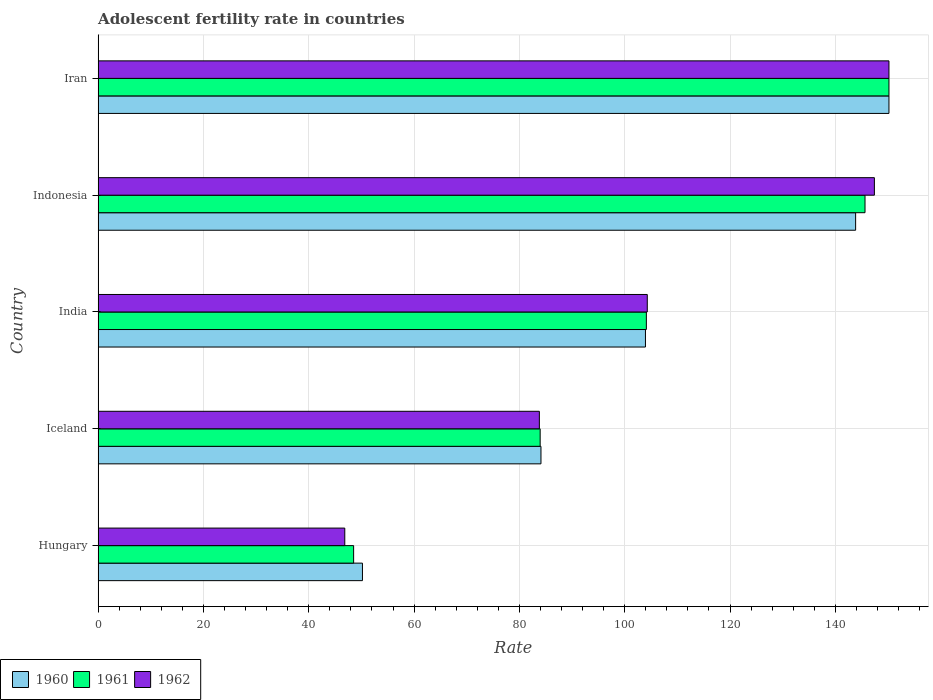How many bars are there on the 4th tick from the top?
Provide a succinct answer. 3. In how many cases, is the number of bars for a given country not equal to the number of legend labels?
Your answer should be very brief. 0. What is the adolescent fertility rate in 1960 in India?
Your answer should be compact. 103.94. Across all countries, what is the maximum adolescent fertility rate in 1962?
Ensure brevity in your answer.  150.18. Across all countries, what is the minimum adolescent fertility rate in 1962?
Your answer should be compact. 46.84. In which country was the adolescent fertility rate in 1962 maximum?
Your response must be concise. Iran. In which country was the adolescent fertility rate in 1962 minimum?
Offer a very short reply. Hungary. What is the total adolescent fertility rate in 1961 in the graph?
Provide a short and direct response. 532.39. What is the difference between the adolescent fertility rate in 1962 in Iceland and that in India?
Your response must be concise. -20.5. What is the difference between the adolescent fertility rate in 1960 in Iceland and the adolescent fertility rate in 1962 in Indonesia?
Ensure brevity in your answer.  -63.32. What is the average adolescent fertility rate in 1961 per country?
Provide a short and direct response. 106.48. What is the difference between the adolescent fertility rate in 1960 and adolescent fertility rate in 1961 in India?
Give a very brief answer. -0.17. In how many countries, is the adolescent fertility rate in 1961 greater than 16 ?
Your answer should be very brief. 5. What is the ratio of the adolescent fertility rate in 1960 in India to that in Iran?
Your answer should be very brief. 0.69. Is the adolescent fertility rate in 1961 in India less than that in Iran?
Provide a succinct answer. Yes. What is the difference between the highest and the second highest adolescent fertility rate in 1960?
Offer a terse response. 6.33. What is the difference between the highest and the lowest adolescent fertility rate in 1962?
Offer a very short reply. 103.34. Is the sum of the adolescent fertility rate in 1960 in India and Iran greater than the maximum adolescent fertility rate in 1962 across all countries?
Provide a succinct answer. Yes. What does the 3rd bar from the top in Indonesia represents?
Keep it short and to the point. 1960. What does the 2nd bar from the bottom in India represents?
Keep it short and to the point. 1961. Are all the bars in the graph horizontal?
Offer a terse response. Yes. How many countries are there in the graph?
Make the answer very short. 5. Does the graph contain any zero values?
Your response must be concise. No. Does the graph contain grids?
Your answer should be compact. Yes. Where does the legend appear in the graph?
Provide a succinct answer. Bottom left. How many legend labels are there?
Provide a succinct answer. 3. How are the legend labels stacked?
Give a very brief answer. Horizontal. What is the title of the graph?
Your answer should be very brief. Adolescent fertility rate in countries. Does "2011" appear as one of the legend labels in the graph?
Keep it short and to the point. No. What is the label or title of the X-axis?
Ensure brevity in your answer.  Rate. What is the label or title of the Y-axis?
Offer a very short reply. Country. What is the Rate in 1960 in Hungary?
Ensure brevity in your answer.  50.2. What is the Rate of 1961 in Hungary?
Your response must be concise. 48.52. What is the Rate of 1962 in Hungary?
Provide a short and direct response. 46.84. What is the Rate in 1960 in Iceland?
Make the answer very short. 84.1. What is the Rate of 1961 in Iceland?
Provide a succinct answer. 83.94. What is the Rate in 1962 in Iceland?
Keep it short and to the point. 83.79. What is the Rate of 1960 in India?
Offer a terse response. 103.94. What is the Rate of 1961 in India?
Make the answer very short. 104.11. What is the Rate in 1962 in India?
Provide a succinct answer. 104.29. What is the Rate in 1960 in Indonesia?
Ensure brevity in your answer.  143.85. What is the Rate in 1961 in Indonesia?
Your response must be concise. 145.63. What is the Rate of 1962 in Indonesia?
Your response must be concise. 147.41. What is the Rate in 1960 in Iran?
Your answer should be very brief. 150.18. What is the Rate in 1961 in Iran?
Your response must be concise. 150.18. What is the Rate of 1962 in Iran?
Provide a short and direct response. 150.18. Across all countries, what is the maximum Rate of 1960?
Provide a succinct answer. 150.18. Across all countries, what is the maximum Rate of 1961?
Your response must be concise. 150.18. Across all countries, what is the maximum Rate of 1962?
Give a very brief answer. 150.18. Across all countries, what is the minimum Rate of 1960?
Your response must be concise. 50.2. Across all countries, what is the minimum Rate in 1961?
Provide a short and direct response. 48.52. Across all countries, what is the minimum Rate of 1962?
Provide a succinct answer. 46.84. What is the total Rate in 1960 in the graph?
Your answer should be compact. 532.26. What is the total Rate of 1961 in the graph?
Your answer should be compact. 532.39. What is the total Rate in 1962 in the graph?
Your answer should be very brief. 532.51. What is the difference between the Rate of 1960 in Hungary and that in Iceland?
Provide a short and direct response. -33.9. What is the difference between the Rate in 1961 in Hungary and that in Iceland?
Offer a very short reply. -35.42. What is the difference between the Rate of 1962 in Hungary and that in Iceland?
Your answer should be very brief. -36.95. What is the difference between the Rate in 1960 in Hungary and that in India?
Keep it short and to the point. -53.74. What is the difference between the Rate in 1961 in Hungary and that in India?
Ensure brevity in your answer.  -55.59. What is the difference between the Rate of 1962 in Hungary and that in India?
Provide a short and direct response. -57.45. What is the difference between the Rate of 1960 in Hungary and that in Indonesia?
Keep it short and to the point. -93.65. What is the difference between the Rate in 1961 in Hungary and that in Indonesia?
Make the answer very short. -97.11. What is the difference between the Rate of 1962 in Hungary and that in Indonesia?
Keep it short and to the point. -100.57. What is the difference between the Rate of 1960 in Hungary and that in Iran?
Offer a very short reply. -99.98. What is the difference between the Rate of 1961 in Hungary and that in Iran?
Offer a very short reply. -101.66. What is the difference between the Rate in 1962 in Hungary and that in Iran?
Make the answer very short. -103.34. What is the difference between the Rate of 1960 in Iceland and that in India?
Keep it short and to the point. -19.84. What is the difference between the Rate in 1961 in Iceland and that in India?
Keep it short and to the point. -20.17. What is the difference between the Rate of 1962 in Iceland and that in India?
Ensure brevity in your answer.  -20.5. What is the difference between the Rate in 1960 in Iceland and that in Indonesia?
Give a very brief answer. -59.75. What is the difference between the Rate in 1961 in Iceland and that in Indonesia?
Give a very brief answer. -61.69. What is the difference between the Rate of 1962 in Iceland and that in Indonesia?
Provide a short and direct response. -63.62. What is the difference between the Rate of 1960 in Iceland and that in Iran?
Ensure brevity in your answer.  -66.08. What is the difference between the Rate in 1961 in Iceland and that in Iran?
Your answer should be very brief. -66.23. What is the difference between the Rate in 1962 in Iceland and that in Iran?
Provide a succinct answer. -66.39. What is the difference between the Rate in 1960 in India and that in Indonesia?
Your answer should be compact. -39.91. What is the difference between the Rate in 1961 in India and that in Indonesia?
Your response must be concise. -41.52. What is the difference between the Rate in 1962 in India and that in Indonesia?
Give a very brief answer. -43.13. What is the difference between the Rate in 1960 in India and that in Iran?
Ensure brevity in your answer.  -46.24. What is the difference between the Rate of 1961 in India and that in Iran?
Provide a short and direct response. -46.07. What is the difference between the Rate in 1962 in India and that in Iran?
Offer a terse response. -45.89. What is the difference between the Rate in 1960 in Indonesia and that in Iran?
Provide a short and direct response. -6.33. What is the difference between the Rate of 1961 in Indonesia and that in Iran?
Keep it short and to the point. -4.55. What is the difference between the Rate of 1962 in Indonesia and that in Iran?
Your answer should be compact. -2.77. What is the difference between the Rate in 1960 in Hungary and the Rate in 1961 in Iceland?
Ensure brevity in your answer.  -33.75. What is the difference between the Rate in 1960 in Hungary and the Rate in 1962 in Iceland?
Provide a succinct answer. -33.59. What is the difference between the Rate in 1961 in Hungary and the Rate in 1962 in Iceland?
Your response must be concise. -35.27. What is the difference between the Rate in 1960 in Hungary and the Rate in 1961 in India?
Keep it short and to the point. -53.91. What is the difference between the Rate of 1960 in Hungary and the Rate of 1962 in India?
Make the answer very short. -54.09. What is the difference between the Rate in 1961 in Hungary and the Rate in 1962 in India?
Make the answer very short. -55.77. What is the difference between the Rate of 1960 in Hungary and the Rate of 1961 in Indonesia?
Give a very brief answer. -95.43. What is the difference between the Rate in 1960 in Hungary and the Rate in 1962 in Indonesia?
Offer a terse response. -97.21. What is the difference between the Rate in 1961 in Hungary and the Rate in 1962 in Indonesia?
Provide a short and direct response. -98.89. What is the difference between the Rate of 1960 in Hungary and the Rate of 1961 in Iran?
Keep it short and to the point. -99.98. What is the difference between the Rate in 1960 in Hungary and the Rate in 1962 in Iran?
Keep it short and to the point. -99.98. What is the difference between the Rate in 1961 in Hungary and the Rate in 1962 in Iran?
Your answer should be compact. -101.66. What is the difference between the Rate in 1960 in Iceland and the Rate in 1961 in India?
Provide a short and direct response. -20.01. What is the difference between the Rate in 1960 in Iceland and the Rate in 1962 in India?
Provide a short and direct response. -20.19. What is the difference between the Rate in 1961 in Iceland and the Rate in 1962 in India?
Your answer should be very brief. -20.34. What is the difference between the Rate in 1960 in Iceland and the Rate in 1961 in Indonesia?
Your answer should be very brief. -61.53. What is the difference between the Rate in 1960 in Iceland and the Rate in 1962 in Indonesia?
Your answer should be very brief. -63.32. What is the difference between the Rate in 1961 in Iceland and the Rate in 1962 in Indonesia?
Make the answer very short. -63.47. What is the difference between the Rate of 1960 in Iceland and the Rate of 1961 in Iran?
Provide a succinct answer. -66.08. What is the difference between the Rate of 1960 in Iceland and the Rate of 1962 in Iran?
Make the answer very short. -66.08. What is the difference between the Rate in 1961 in Iceland and the Rate in 1962 in Iran?
Provide a short and direct response. -66.23. What is the difference between the Rate of 1960 in India and the Rate of 1961 in Indonesia?
Make the answer very short. -41.69. What is the difference between the Rate in 1960 in India and the Rate in 1962 in Indonesia?
Provide a short and direct response. -43.48. What is the difference between the Rate of 1961 in India and the Rate of 1962 in Indonesia?
Keep it short and to the point. -43.3. What is the difference between the Rate in 1960 in India and the Rate in 1961 in Iran?
Your answer should be compact. -46.24. What is the difference between the Rate in 1960 in India and the Rate in 1962 in Iran?
Your response must be concise. -46.24. What is the difference between the Rate in 1961 in India and the Rate in 1962 in Iran?
Your answer should be compact. -46.07. What is the difference between the Rate of 1960 in Indonesia and the Rate of 1961 in Iran?
Provide a short and direct response. -6.33. What is the difference between the Rate in 1960 in Indonesia and the Rate in 1962 in Iran?
Your response must be concise. -6.33. What is the difference between the Rate of 1961 in Indonesia and the Rate of 1962 in Iran?
Offer a terse response. -4.55. What is the average Rate in 1960 per country?
Make the answer very short. 106.45. What is the average Rate in 1961 per country?
Provide a short and direct response. 106.48. What is the average Rate in 1962 per country?
Offer a terse response. 106.5. What is the difference between the Rate of 1960 and Rate of 1961 in Hungary?
Make the answer very short. 1.68. What is the difference between the Rate of 1960 and Rate of 1962 in Hungary?
Offer a terse response. 3.36. What is the difference between the Rate of 1961 and Rate of 1962 in Hungary?
Provide a short and direct response. 1.68. What is the difference between the Rate in 1960 and Rate in 1961 in Iceland?
Offer a terse response. 0.15. What is the difference between the Rate of 1960 and Rate of 1962 in Iceland?
Your answer should be very brief. 0.31. What is the difference between the Rate in 1961 and Rate in 1962 in Iceland?
Make the answer very short. 0.15. What is the difference between the Rate of 1960 and Rate of 1961 in India?
Offer a very short reply. -0.17. What is the difference between the Rate in 1960 and Rate in 1962 in India?
Offer a very short reply. -0.35. What is the difference between the Rate in 1961 and Rate in 1962 in India?
Provide a succinct answer. -0.17. What is the difference between the Rate of 1960 and Rate of 1961 in Indonesia?
Give a very brief answer. -1.78. What is the difference between the Rate in 1960 and Rate in 1962 in Indonesia?
Offer a very short reply. -3.56. What is the difference between the Rate of 1961 and Rate of 1962 in Indonesia?
Ensure brevity in your answer.  -1.78. What is the difference between the Rate of 1960 and Rate of 1962 in Iran?
Keep it short and to the point. 0. What is the ratio of the Rate of 1960 in Hungary to that in Iceland?
Provide a succinct answer. 0.6. What is the ratio of the Rate of 1961 in Hungary to that in Iceland?
Your response must be concise. 0.58. What is the ratio of the Rate of 1962 in Hungary to that in Iceland?
Offer a very short reply. 0.56. What is the ratio of the Rate in 1960 in Hungary to that in India?
Your answer should be compact. 0.48. What is the ratio of the Rate in 1961 in Hungary to that in India?
Offer a terse response. 0.47. What is the ratio of the Rate in 1962 in Hungary to that in India?
Give a very brief answer. 0.45. What is the ratio of the Rate in 1960 in Hungary to that in Indonesia?
Offer a terse response. 0.35. What is the ratio of the Rate of 1961 in Hungary to that in Indonesia?
Your answer should be very brief. 0.33. What is the ratio of the Rate of 1962 in Hungary to that in Indonesia?
Offer a terse response. 0.32. What is the ratio of the Rate in 1960 in Hungary to that in Iran?
Your answer should be very brief. 0.33. What is the ratio of the Rate in 1961 in Hungary to that in Iran?
Your answer should be compact. 0.32. What is the ratio of the Rate in 1962 in Hungary to that in Iran?
Provide a short and direct response. 0.31. What is the ratio of the Rate of 1960 in Iceland to that in India?
Your answer should be very brief. 0.81. What is the ratio of the Rate of 1961 in Iceland to that in India?
Offer a terse response. 0.81. What is the ratio of the Rate of 1962 in Iceland to that in India?
Ensure brevity in your answer.  0.8. What is the ratio of the Rate in 1960 in Iceland to that in Indonesia?
Keep it short and to the point. 0.58. What is the ratio of the Rate of 1961 in Iceland to that in Indonesia?
Offer a very short reply. 0.58. What is the ratio of the Rate in 1962 in Iceland to that in Indonesia?
Give a very brief answer. 0.57. What is the ratio of the Rate of 1960 in Iceland to that in Iran?
Keep it short and to the point. 0.56. What is the ratio of the Rate of 1961 in Iceland to that in Iran?
Keep it short and to the point. 0.56. What is the ratio of the Rate in 1962 in Iceland to that in Iran?
Give a very brief answer. 0.56. What is the ratio of the Rate of 1960 in India to that in Indonesia?
Give a very brief answer. 0.72. What is the ratio of the Rate of 1961 in India to that in Indonesia?
Ensure brevity in your answer.  0.71. What is the ratio of the Rate in 1962 in India to that in Indonesia?
Provide a short and direct response. 0.71. What is the ratio of the Rate in 1960 in India to that in Iran?
Ensure brevity in your answer.  0.69. What is the ratio of the Rate of 1961 in India to that in Iran?
Provide a succinct answer. 0.69. What is the ratio of the Rate of 1962 in India to that in Iran?
Offer a very short reply. 0.69. What is the ratio of the Rate of 1960 in Indonesia to that in Iran?
Provide a short and direct response. 0.96. What is the ratio of the Rate of 1961 in Indonesia to that in Iran?
Give a very brief answer. 0.97. What is the ratio of the Rate in 1962 in Indonesia to that in Iran?
Offer a very short reply. 0.98. What is the difference between the highest and the second highest Rate in 1960?
Offer a very short reply. 6.33. What is the difference between the highest and the second highest Rate in 1961?
Your response must be concise. 4.55. What is the difference between the highest and the second highest Rate of 1962?
Offer a terse response. 2.77. What is the difference between the highest and the lowest Rate of 1960?
Your response must be concise. 99.98. What is the difference between the highest and the lowest Rate in 1961?
Your response must be concise. 101.66. What is the difference between the highest and the lowest Rate in 1962?
Offer a very short reply. 103.34. 